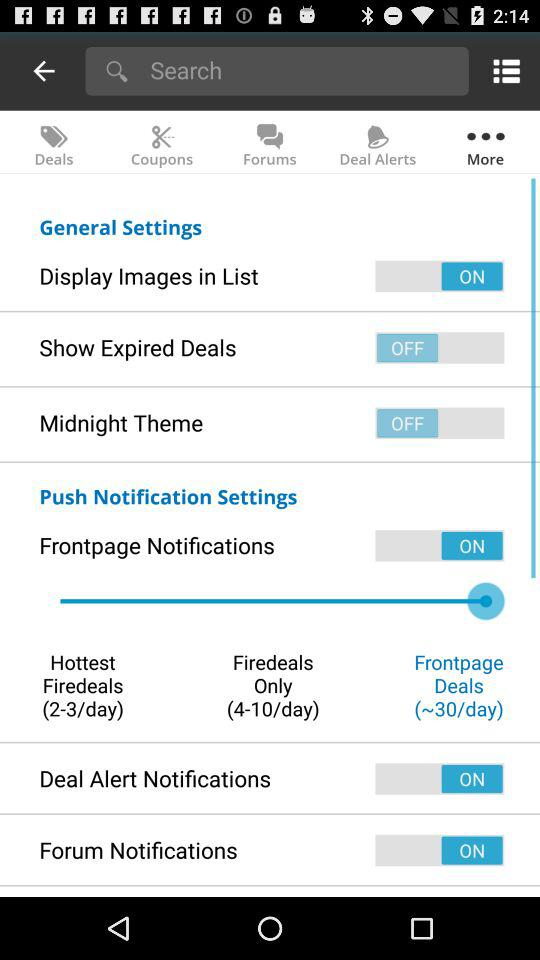What is the total number of "Firedeals Only" per day? The total number of "Firedeals Only" per day is 4-10. 